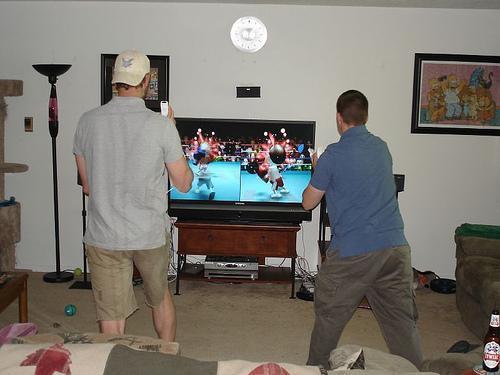How many people are visible in the room?
Give a very brief answer. 2. How many people are in the photo?
Give a very brief answer. 2. How many couches are visible?
Give a very brief answer. 2. How many horses are pulling the buggy?
Give a very brief answer. 0. 